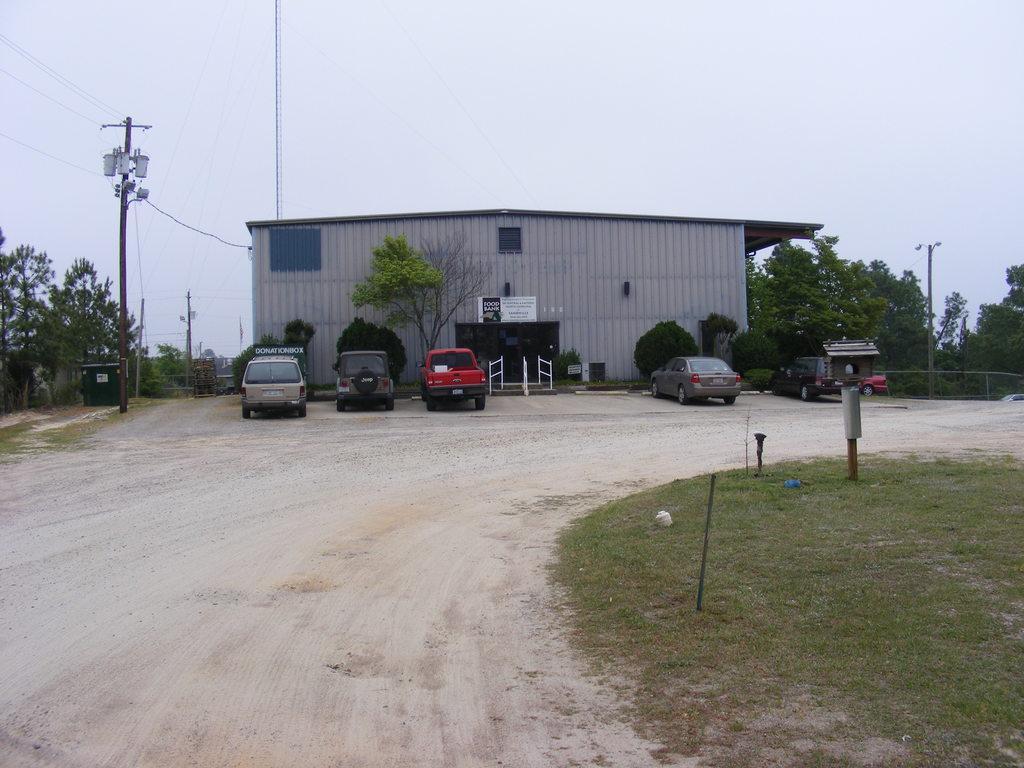Describe this image in one or two sentences. In this image we can see a building and in front of the building we can see some vehicles are parked and there is a road. To the side we can see the ground with grass and in the background, we can see some plants and trees. We can see the power pole and we can also see the sky. 